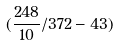<formula> <loc_0><loc_0><loc_500><loc_500>( \frac { 2 4 8 } { 1 0 } / 3 7 2 - 4 3 )</formula> 